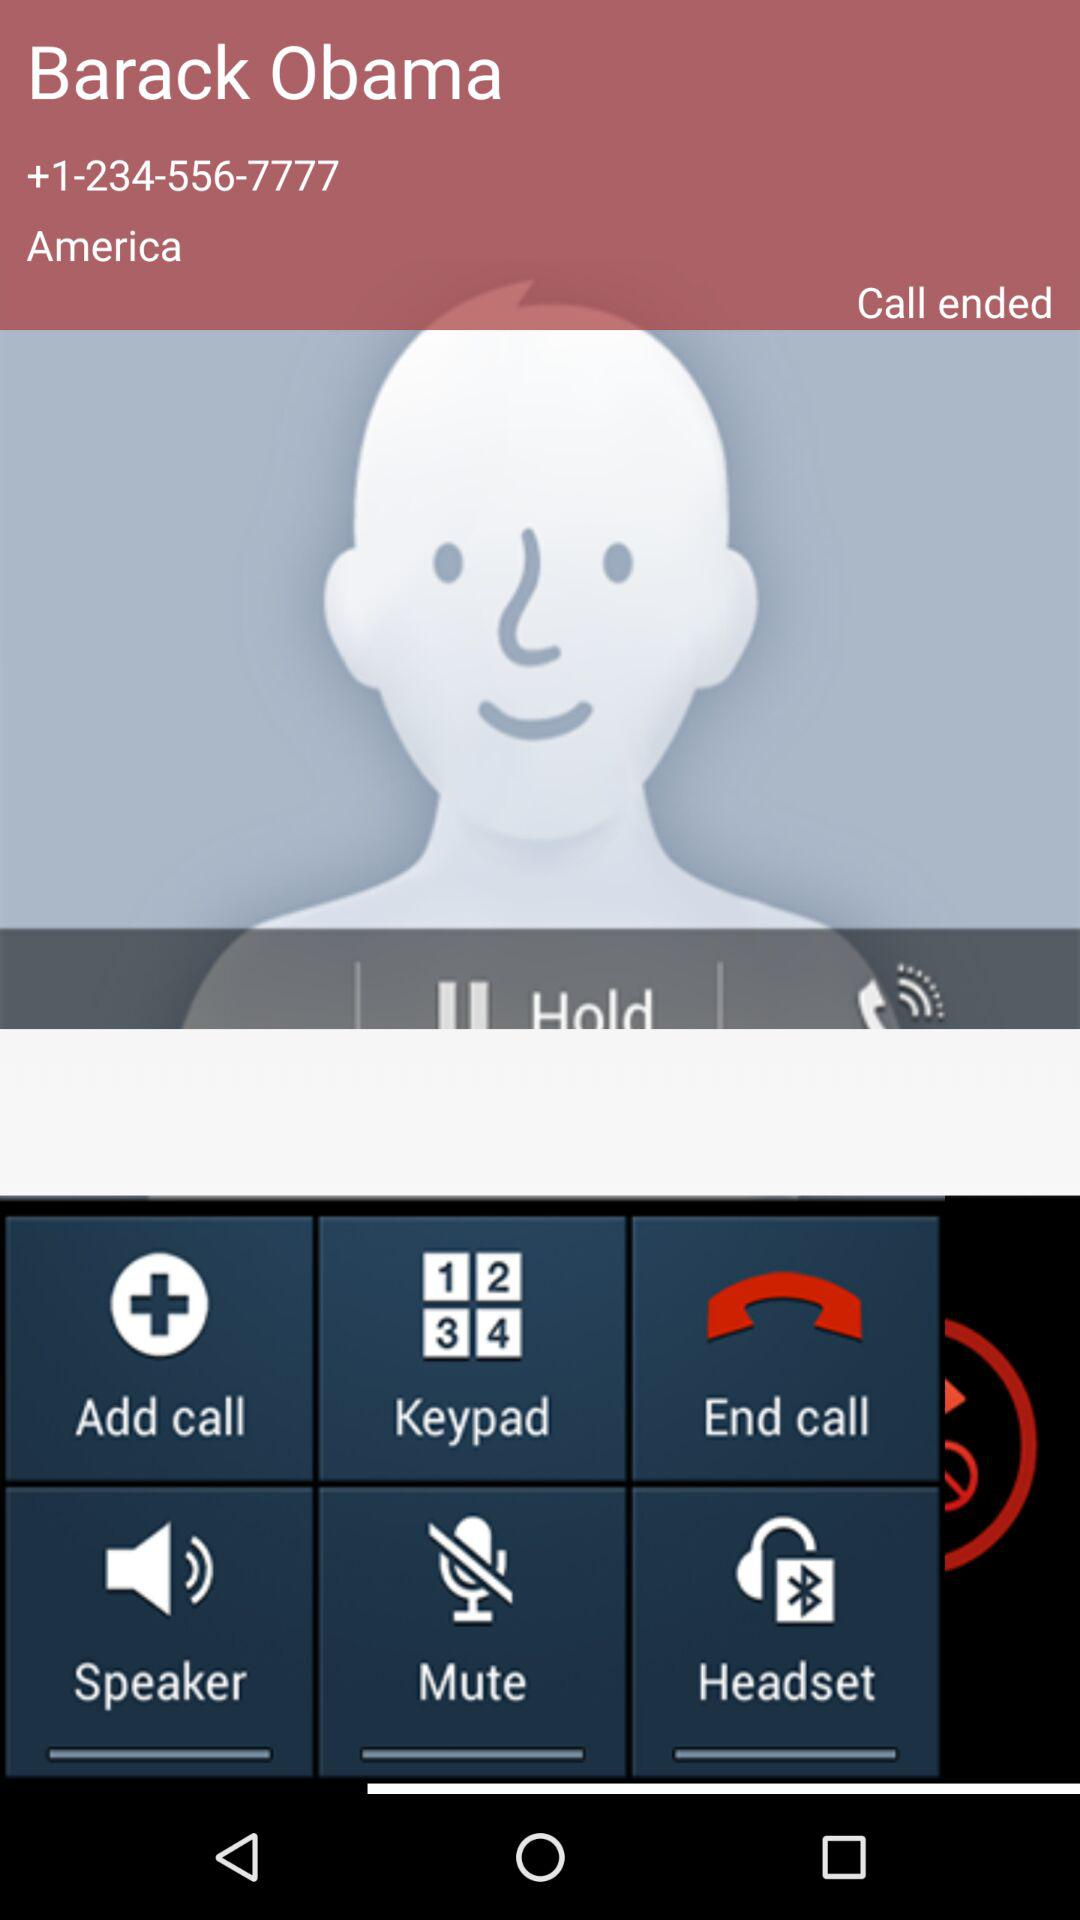From what country did the call come? The call came from America. 